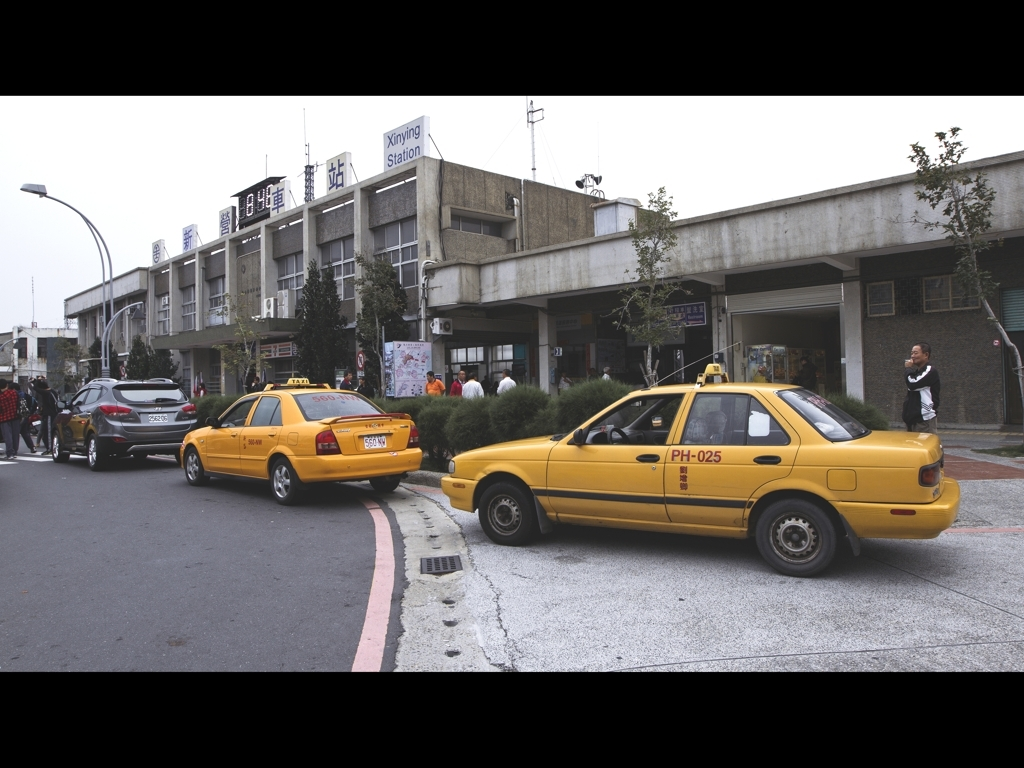Can you describe the scene depicted in this image? The image shows a street view with several taxicabs, both parked and in motion, near what appears to be a train station entrance. The station has visible signage indicating it is 'Xinying Station.' There are multiple people, going about their day, including a person standing near the station entrance. It seems to be an overcast day, and the overall ambiance is that of a busy transportation hub. What might a local resident find interesting in this photo? A local resident might recognize the taxi company's branding, which could be a familiar sight in this area. They might also have personal experiences or memories associated with the Xinying Station, making this image nostalgic or personally relevant. Additionally, the presence of multiple taxis might suggest this is a common spot for catching a ride, indicating the photo captures an everyday aspect of local life. 